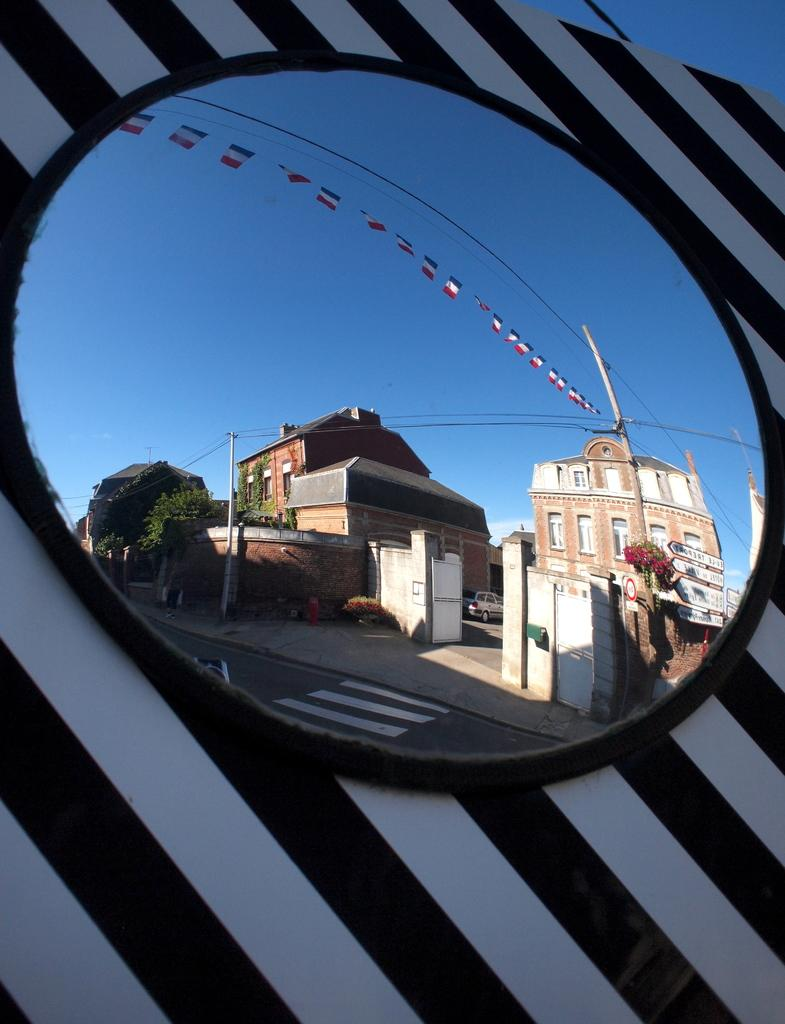What object is attached to the wall in the image? There is a mirror on the wall in the image. What does the mirror reflect in the image? The mirror reflects a view of the road, including current poles, trees, buildings, a car, and the sky. Can you describe the reflected view in more detail? The reflected view includes current poles, trees, buildings, a car, and the sky. What type of vegetable is being sold at the lowest price in the image? There is no reference to any vegetables or prices in the image; it features a mirror reflecting a view of the road. 